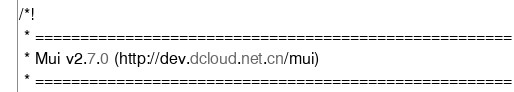Convert code to text. <code><loc_0><loc_0><loc_500><loc_500><_CSS_>/*!
 * =====================================================
 * Mui v2.7.0 (http://dev.dcloud.net.cn/mui)
 * =====================================================</code> 